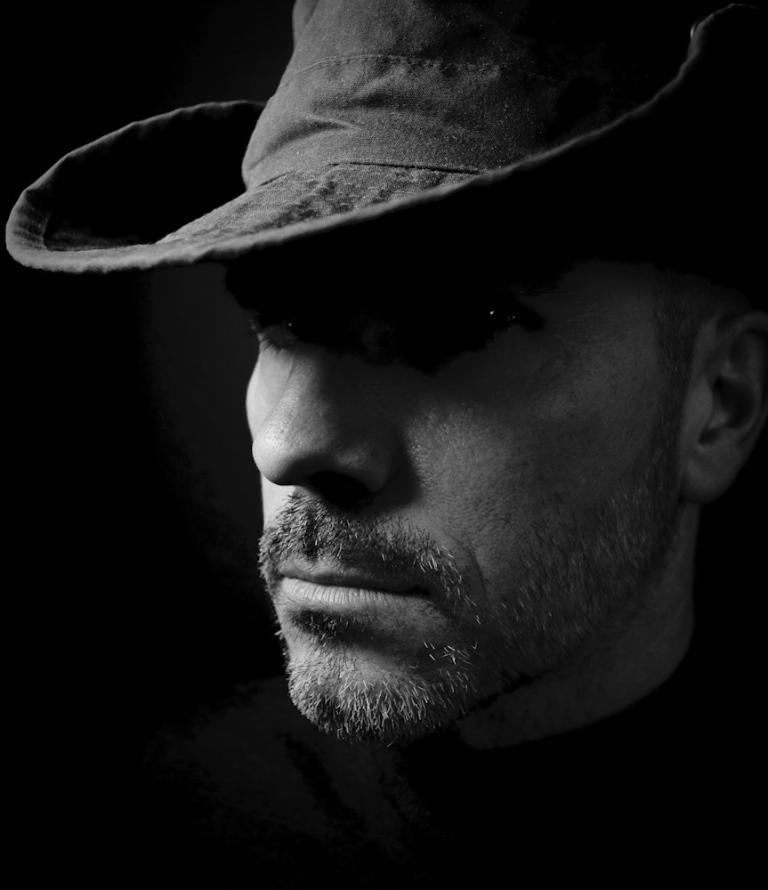Please provide a concise description of this image. This is a black and white image. In this image we can see a man wearing a hat. 